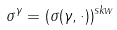<formula> <loc_0><loc_0><loc_500><loc_500>\sigma ^ { \gamma } = ( \sigma ( \gamma , \cdot ) ) ^ { s k w }</formula> 